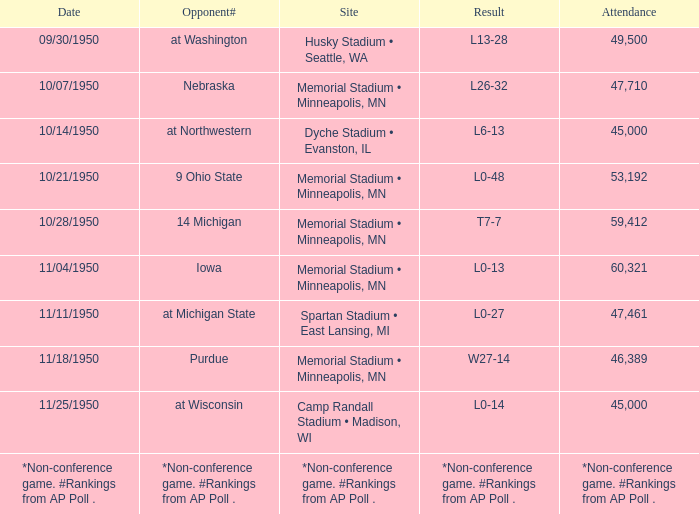What is the date when the site is memorial stadium • minneapolis, mn, and the attendance is 53,192? 10/21/1950. 